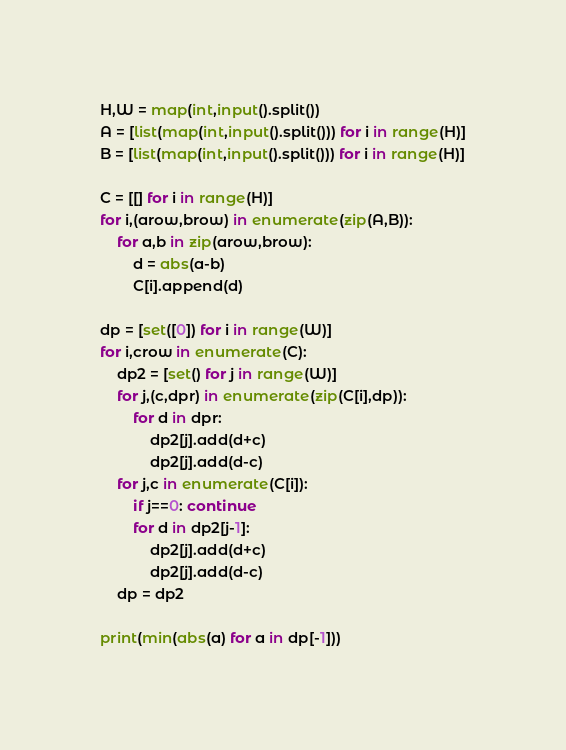Convert code to text. <code><loc_0><loc_0><loc_500><loc_500><_Python_>H,W = map(int,input().split())
A = [list(map(int,input().split())) for i in range(H)]
B = [list(map(int,input().split())) for i in range(H)]

C = [[] for i in range(H)]
for i,(arow,brow) in enumerate(zip(A,B)):
    for a,b in zip(arow,brow):
        d = abs(a-b)
        C[i].append(d)

dp = [set([0]) for i in range(W)]
for i,crow in enumerate(C):
    dp2 = [set() for j in range(W)]
    for j,(c,dpr) in enumerate(zip(C[i],dp)):
        for d in dpr:
            dp2[j].add(d+c)
            dp2[j].add(d-c)
    for j,c in enumerate(C[i]):
        if j==0: continue
        for d in dp2[j-1]:
            dp2[j].add(d+c)
            dp2[j].add(d-c)
    dp = dp2

print(min(abs(a) for a in dp[-1]))</code> 